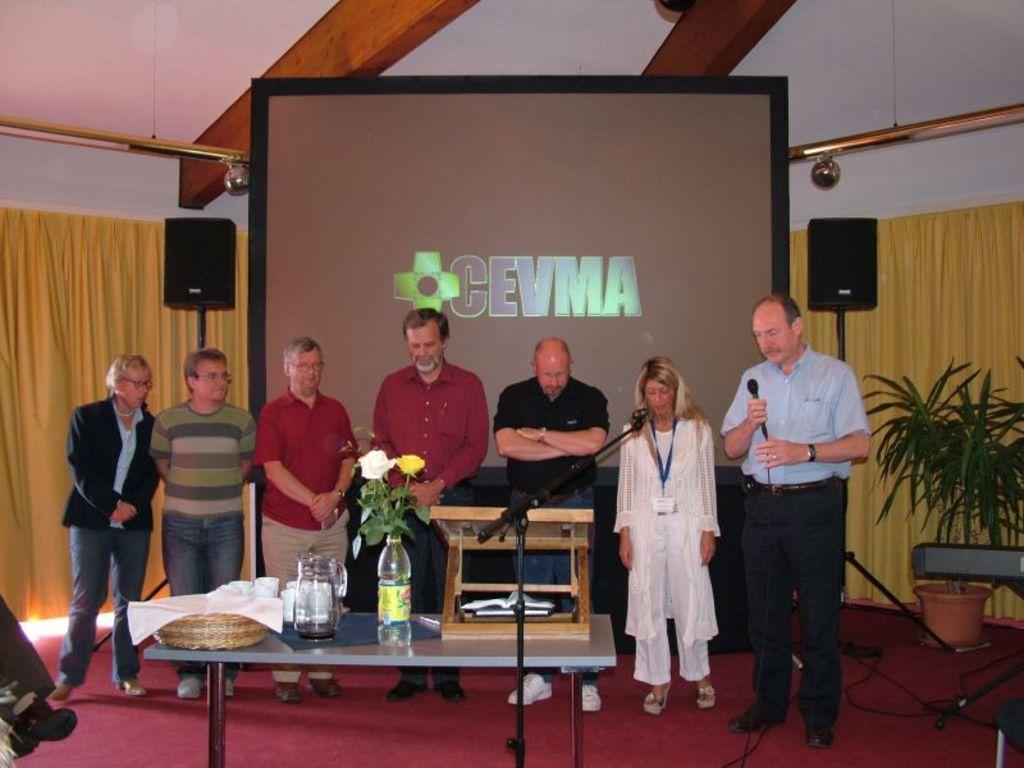Could you give a brief overview of what you see in this image? There are some people standing. In the right a person is holding mic and wearing watch. In the front there is a table. On the table there is a bottle with flowers, jar, basket with cloth, and some mugs, there are some books. In the floor there is a red carpet. In the background there is a screen, two speakers, yellow curtains. On the right side there is a plant with pot. 